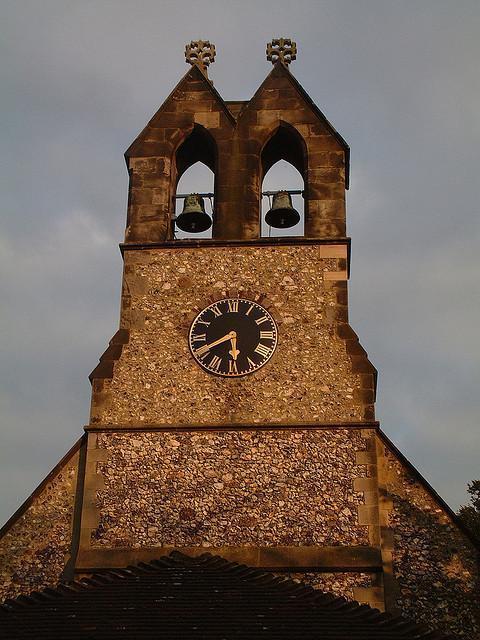How many bells are there?
Give a very brief answer. 2. How many clocks are in the picture?
Give a very brief answer. 1. How many women are present?
Give a very brief answer. 0. 